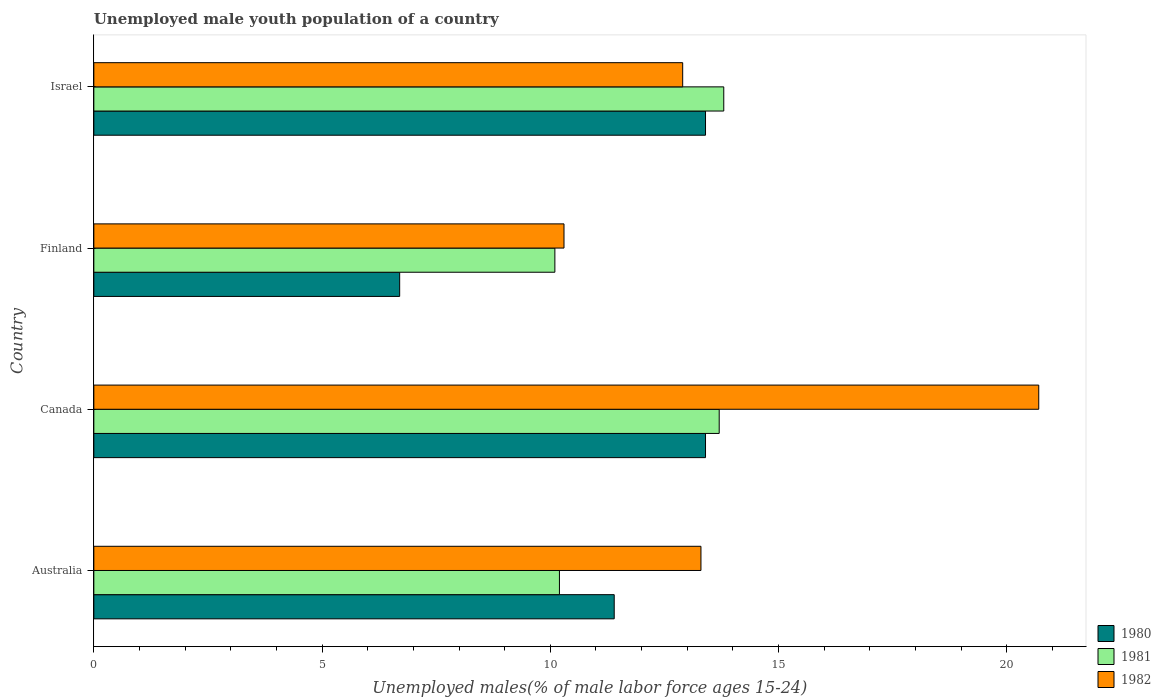Are the number of bars per tick equal to the number of legend labels?
Provide a short and direct response. Yes. Are the number of bars on each tick of the Y-axis equal?
Your answer should be compact. Yes. How many bars are there on the 4th tick from the bottom?
Make the answer very short. 3. What is the percentage of unemployed male youth population in 1980 in Canada?
Ensure brevity in your answer.  13.4. Across all countries, what is the maximum percentage of unemployed male youth population in 1981?
Keep it short and to the point. 13.8. Across all countries, what is the minimum percentage of unemployed male youth population in 1981?
Offer a terse response. 10.1. In which country was the percentage of unemployed male youth population in 1982 minimum?
Your answer should be very brief. Finland. What is the total percentage of unemployed male youth population in 1982 in the graph?
Your answer should be compact. 57.2. What is the difference between the percentage of unemployed male youth population in 1981 in Canada and that in Israel?
Make the answer very short. -0.1. What is the difference between the percentage of unemployed male youth population in 1980 in Israel and the percentage of unemployed male youth population in 1982 in Finland?
Give a very brief answer. 3.1. What is the average percentage of unemployed male youth population in 1981 per country?
Your answer should be very brief. 11.95. What is the difference between the percentage of unemployed male youth population in 1980 and percentage of unemployed male youth population in 1981 in Finland?
Offer a terse response. -3.4. What is the ratio of the percentage of unemployed male youth population in 1982 in Canada to that in Israel?
Your response must be concise. 1.6. Is the percentage of unemployed male youth population in 1982 in Australia less than that in Finland?
Keep it short and to the point. No. Is the difference between the percentage of unemployed male youth population in 1980 in Australia and Israel greater than the difference between the percentage of unemployed male youth population in 1981 in Australia and Israel?
Your response must be concise. Yes. What is the difference between the highest and the second highest percentage of unemployed male youth population in 1982?
Give a very brief answer. 7.4. What is the difference between the highest and the lowest percentage of unemployed male youth population in 1982?
Your answer should be very brief. 10.4. In how many countries, is the percentage of unemployed male youth population in 1981 greater than the average percentage of unemployed male youth population in 1981 taken over all countries?
Offer a terse response. 2. What does the 3rd bar from the bottom in Israel represents?
Your answer should be compact. 1982. Is it the case that in every country, the sum of the percentage of unemployed male youth population in 1982 and percentage of unemployed male youth population in 1981 is greater than the percentage of unemployed male youth population in 1980?
Make the answer very short. Yes. How many bars are there?
Keep it short and to the point. 12. Are all the bars in the graph horizontal?
Your answer should be compact. Yes. What is the difference between two consecutive major ticks on the X-axis?
Ensure brevity in your answer.  5. Are the values on the major ticks of X-axis written in scientific E-notation?
Offer a terse response. No. Does the graph contain any zero values?
Provide a succinct answer. No. Does the graph contain grids?
Give a very brief answer. No. Where does the legend appear in the graph?
Your response must be concise. Bottom right. How many legend labels are there?
Ensure brevity in your answer.  3. How are the legend labels stacked?
Provide a succinct answer. Vertical. What is the title of the graph?
Give a very brief answer. Unemployed male youth population of a country. What is the label or title of the X-axis?
Your answer should be compact. Unemployed males(% of male labor force ages 15-24). What is the Unemployed males(% of male labor force ages 15-24) of 1980 in Australia?
Give a very brief answer. 11.4. What is the Unemployed males(% of male labor force ages 15-24) in 1981 in Australia?
Make the answer very short. 10.2. What is the Unemployed males(% of male labor force ages 15-24) of 1982 in Australia?
Provide a short and direct response. 13.3. What is the Unemployed males(% of male labor force ages 15-24) of 1980 in Canada?
Keep it short and to the point. 13.4. What is the Unemployed males(% of male labor force ages 15-24) of 1981 in Canada?
Provide a succinct answer. 13.7. What is the Unemployed males(% of male labor force ages 15-24) in 1982 in Canada?
Offer a very short reply. 20.7. What is the Unemployed males(% of male labor force ages 15-24) in 1980 in Finland?
Provide a succinct answer. 6.7. What is the Unemployed males(% of male labor force ages 15-24) of 1981 in Finland?
Offer a terse response. 10.1. What is the Unemployed males(% of male labor force ages 15-24) in 1982 in Finland?
Offer a very short reply. 10.3. What is the Unemployed males(% of male labor force ages 15-24) of 1980 in Israel?
Provide a short and direct response. 13.4. What is the Unemployed males(% of male labor force ages 15-24) of 1981 in Israel?
Keep it short and to the point. 13.8. What is the Unemployed males(% of male labor force ages 15-24) in 1982 in Israel?
Provide a short and direct response. 12.9. Across all countries, what is the maximum Unemployed males(% of male labor force ages 15-24) in 1980?
Your answer should be very brief. 13.4. Across all countries, what is the maximum Unemployed males(% of male labor force ages 15-24) in 1981?
Provide a succinct answer. 13.8. Across all countries, what is the maximum Unemployed males(% of male labor force ages 15-24) in 1982?
Provide a succinct answer. 20.7. Across all countries, what is the minimum Unemployed males(% of male labor force ages 15-24) of 1980?
Provide a succinct answer. 6.7. Across all countries, what is the minimum Unemployed males(% of male labor force ages 15-24) of 1981?
Provide a succinct answer. 10.1. Across all countries, what is the minimum Unemployed males(% of male labor force ages 15-24) of 1982?
Ensure brevity in your answer.  10.3. What is the total Unemployed males(% of male labor force ages 15-24) of 1980 in the graph?
Provide a succinct answer. 44.9. What is the total Unemployed males(% of male labor force ages 15-24) of 1981 in the graph?
Your answer should be very brief. 47.8. What is the total Unemployed males(% of male labor force ages 15-24) in 1982 in the graph?
Provide a short and direct response. 57.2. What is the difference between the Unemployed males(% of male labor force ages 15-24) of 1980 in Australia and that in Canada?
Make the answer very short. -2. What is the difference between the Unemployed males(% of male labor force ages 15-24) in 1981 in Australia and that in Canada?
Offer a terse response. -3.5. What is the difference between the Unemployed males(% of male labor force ages 15-24) in 1982 in Australia and that in Canada?
Offer a very short reply. -7.4. What is the difference between the Unemployed males(% of male labor force ages 15-24) in 1980 in Australia and that in Finland?
Your answer should be very brief. 4.7. What is the difference between the Unemployed males(% of male labor force ages 15-24) in 1981 in Australia and that in Finland?
Offer a very short reply. 0.1. What is the difference between the Unemployed males(% of male labor force ages 15-24) in 1982 in Australia and that in Finland?
Your response must be concise. 3. What is the difference between the Unemployed males(% of male labor force ages 15-24) in 1980 in Australia and that in Israel?
Keep it short and to the point. -2. What is the difference between the Unemployed males(% of male labor force ages 15-24) of 1981 in Australia and that in Israel?
Your answer should be very brief. -3.6. What is the difference between the Unemployed males(% of male labor force ages 15-24) of 1981 in Canada and that in Israel?
Offer a terse response. -0.1. What is the difference between the Unemployed males(% of male labor force ages 15-24) in 1981 in Finland and that in Israel?
Offer a terse response. -3.7. What is the difference between the Unemployed males(% of male labor force ages 15-24) in 1982 in Finland and that in Israel?
Give a very brief answer. -2.6. What is the difference between the Unemployed males(% of male labor force ages 15-24) in 1980 in Australia and the Unemployed males(% of male labor force ages 15-24) in 1982 in Canada?
Make the answer very short. -9.3. What is the difference between the Unemployed males(% of male labor force ages 15-24) of 1981 in Australia and the Unemployed males(% of male labor force ages 15-24) of 1982 in Canada?
Give a very brief answer. -10.5. What is the difference between the Unemployed males(% of male labor force ages 15-24) in 1980 in Australia and the Unemployed males(% of male labor force ages 15-24) in 1981 in Finland?
Provide a succinct answer. 1.3. What is the difference between the Unemployed males(% of male labor force ages 15-24) of 1980 in Australia and the Unemployed males(% of male labor force ages 15-24) of 1982 in Finland?
Provide a short and direct response. 1.1. What is the difference between the Unemployed males(% of male labor force ages 15-24) of 1981 in Australia and the Unemployed males(% of male labor force ages 15-24) of 1982 in Finland?
Make the answer very short. -0.1. What is the difference between the Unemployed males(% of male labor force ages 15-24) in 1980 in Australia and the Unemployed males(% of male labor force ages 15-24) in 1982 in Israel?
Provide a short and direct response. -1.5. What is the difference between the Unemployed males(% of male labor force ages 15-24) of 1980 in Canada and the Unemployed males(% of male labor force ages 15-24) of 1981 in Finland?
Keep it short and to the point. 3.3. What is the difference between the Unemployed males(% of male labor force ages 15-24) in 1980 in Canada and the Unemployed males(% of male labor force ages 15-24) in 1981 in Israel?
Your answer should be very brief. -0.4. What is the difference between the Unemployed males(% of male labor force ages 15-24) of 1980 in Finland and the Unemployed males(% of male labor force ages 15-24) of 1981 in Israel?
Your answer should be compact. -7.1. What is the difference between the Unemployed males(% of male labor force ages 15-24) in 1981 in Finland and the Unemployed males(% of male labor force ages 15-24) in 1982 in Israel?
Provide a succinct answer. -2.8. What is the average Unemployed males(% of male labor force ages 15-24) in 1980 per country?
Offer a very short reply. 11.22. What is the average Unemployed males(% of male labor force ages 15-24) in 1981 per country?
Provide a short and direct response. 11.95. What is the difference between the Unemployed males(% of male labor force ages 15-24) of 1980 and Unemployed males(% of male labor force ages 15-24) of 1981 in Australia?
Give a very brief answer. 1.2. What is the difference between the Unemployed males(% of male labor force ages 15-24) in 1981 and Unemployed males(% of male labor force ages 15-24) in 1982 in Canada?
Your response must be concise. -7. What is the difference between the Unemployed males(% of male labor force ages 15-24) in 1981 and Unemployed males(% of male labor force ages 15-24) in 1982 in Finland?
Offer a terse response. -0.2. What is the difference between the Unemployed males(% of male labor force ages 15-24) of 1980 and Unemployed males(% of male labor force ages 15-24) of 1982 in Israel?
Offer a terse response. 0.5. What is the ratio of the Unemployed males(% of male labor force ages 15-24) in 1980 in Australia to that in Canada?
Make the answer very short. 0.85. What is the ratio of the Unemployed males(% of male labor force ages 15-24) in 1981 in Australia to that in Canada?
Your answer should be very brief. 0.74. What is the ratio of the Unemployed males(% of male labor force ages 15-24) in 1982 in Australia to that in Canada?
Make the answer very short. 0.64. What is the ratio of the Unemployed males(% of male labor force ages 15-24) in 1980 in Australia to that in Finland?
Your answer should be very brief. 1.7. What is the ratio of the Unemployed males(% of male labor force ages 15-24) of 1981 in Australia to that in Finland?
Your response must be concise. 1.01. What is the ratio of the Unemployed males(% of male labor force ages 15-24) in 1982 in Australia to that in Finland?
Ensure brevity in your answer.  1.29. What is the ratio of the Unemployed males(% of male labor force ages 15-24) in 1980 in Australia to that in Israel?
Provide a succinct answer. 0.85. What is the ratio of the Unemployed males(% of male labor force ages 15-24) of 1981 in Australia to that in Israel?
Keep it short and to the point. 0.74. What is the ratio of the Unemployed males(% of male labor force ages 15-24) of 1982 in Australia to that in Israel?
Keep it short and to the point. 1.03. What is the ratio of the Unemployed males(% of male labor force ages 15-24) of 1980 in Canada to that in Finland?
Keep it short and to the point. 2. What is the ratio of the Unemployed males(% of male labor force ages 15-24) in 1981 in Canada to that in Finland?
Make the answer very short. 1.36. What is the ratio of the Unemployed males(% of male labor force ages 15-24) in 1982 in Canada to that in Finland?
Give a very brief answer. 2.01. What is the ratio of the Unemployed males(% of male labor force ages 15-24) of 1982 in Canada to that in Israel?
Offer a terse response. 1.6. What is the ratio of the Unemployed males(% of male labor force ages 15-24) in 1980 in Finland to that in Israel?
Keep it short and to the point. 0.5. What is the ratio of the Unemployed males(% of male labor force ages 15-24) in 1981 in Finland to that in Israel?
Offer a terse response. 0.73. What is the ratio of the Unemployed males(% of male labor force ages 15-24) in 1982 in Finland to that in Israel?
Offer a very short reply. 0.8. What is the difference between the highest and the second highest Unemployed males(% of male labor force ages 15-24) of 1980?
Your answer should be compact. 0. What is the difference between the highest and the second highest Unemployed males(% of male labor force ages 15-24) of 1982?
Give a very brief answer. 7.4. What is the difference between the highest and the lowest Unemployed males(% of male labor force ages 15-24) in 1981?
Your answer should be very brief. 3.7. What is the difference between the highest and the lowest Unemployed males(% of male labor force ages 15-24) of 1982?
Make the answer very short. 10.4. 